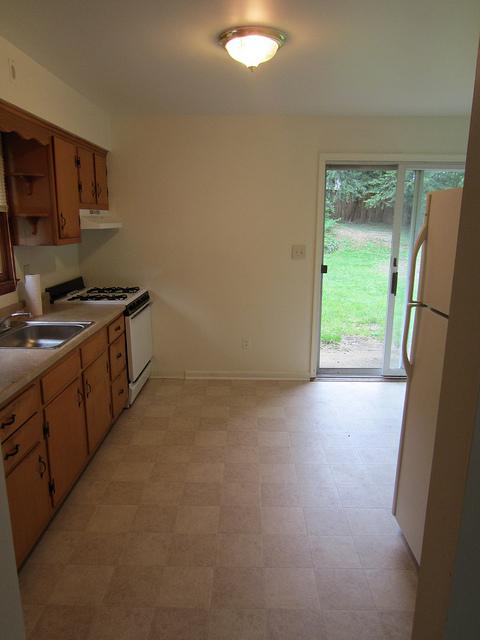Is the door open?
Be succinct. Yes. How many doorways are pictured in the room?
Give a very brief answer. 1. How is the oven integrated into the kitchen?
Give a very brief answer. Corner. What is the flooring made of?
Write a very short answer. Tile. Is the light on?
Concise answer only. Yes. How many lights can be seen?
Answer briefly. 1. What are the floors made from?
Quick response, please. Tile. Does anyone dwell in the home?
Answer briefly. Yes. What is the white object on the kitchen counter?
Answer briefly. Paper towels. Is that an average sized door?
Short answer required. Yes. Do they need a new floor?
Short answer required. No. What is the floor made of?
Concise answer only. Tile. 